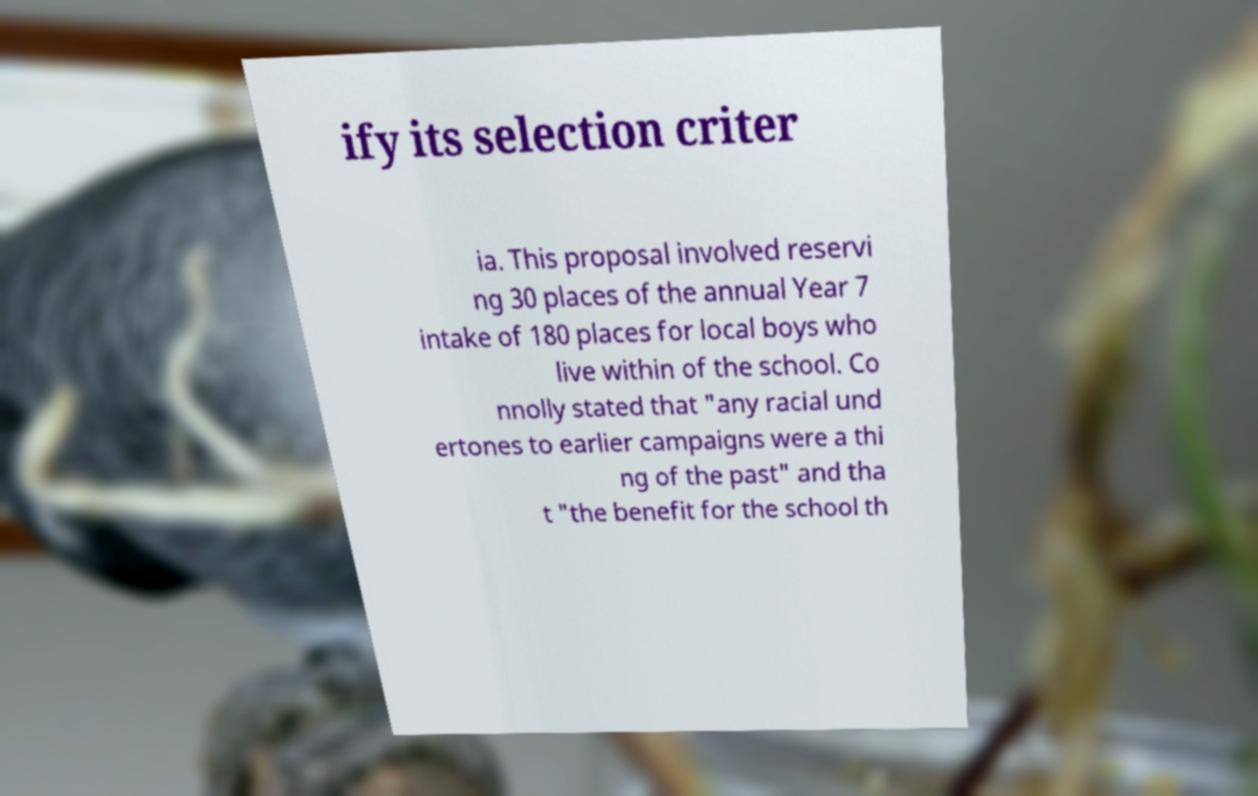What messages or text are displayed in this image? I need them in a readable, typed format. ify its selection criter ia. This proposal involved reservi ng 30 places of the annual Year 7 intake of 180 places for local boys who live within of the school. Co nnolly stated that "any racial und ertones to earlier campaigns were a thi ng of the past" and tha t "the benefit for the school th 